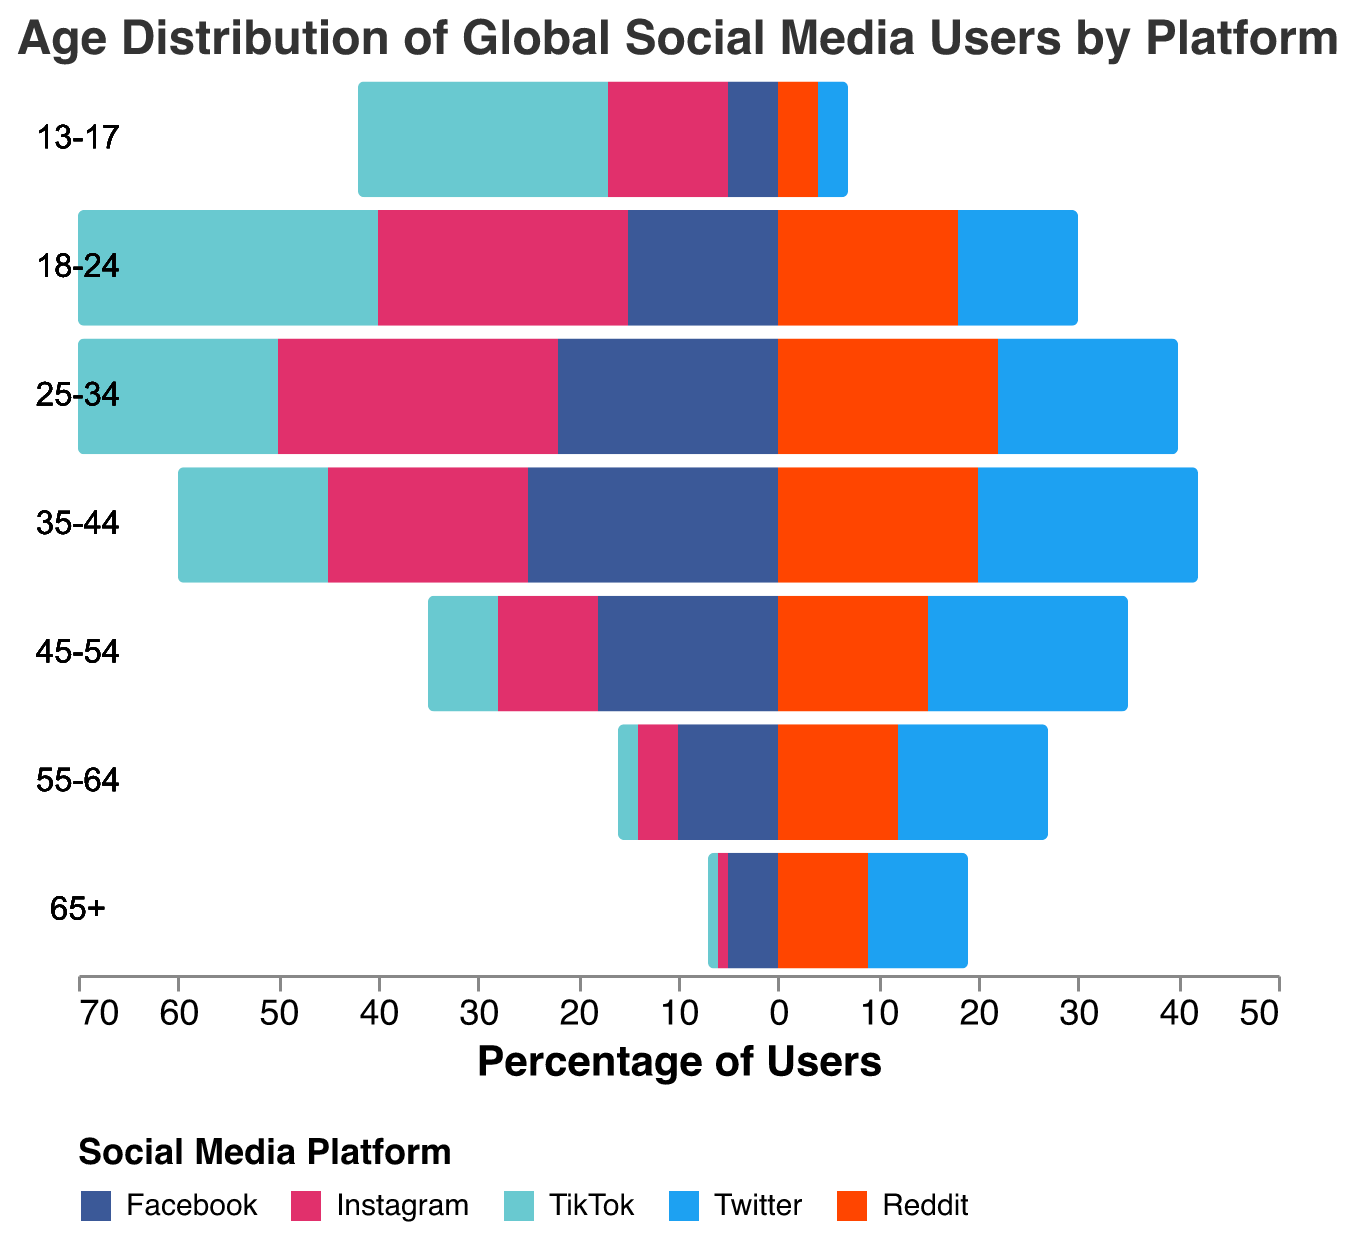What is the age group with the highest percentage of Facebook users? To find the age group with the highest percentage of Facebook users, refer to the bars representing Facebook in different age groups. The tallest bar indicates the age group with the highest percentage.
Answer: 35-44 Which social media platform has the highest user percentage among the 18-24 age group? Look for the bar corresponding to the 18-24 age group and identify the platform with the highest value.
Answer: TikTok How does the percentage of Instagram users in the 45-54 age group compare to the percentage of Reddit users in the same age group? Compare the heights of the Instagram and Reddit bars for the 45-54 age group.
Answer: Reddit is higher What is the combined percentage of TikTok users in the 13-17 and 18-24 age groups? Add the percentages of TikTok users for the 13-17 and 18-24 age groups: 25 (13-17) + 30 (18-24) = 55.
Answer: 55 Which age group has the smallest percentage of Instagram users? Identify the smallest bar for Instagram across all age groups.
Answer: 65+ What trend can be observed in the use of Facebook as age increases? Observe the pattern of Facebook bar heights across different age groups. The usage seems to peak in middle age and decrease towards the older and younger ends.
Answer: Peaks around 35-44, decreases towards edges Compare the percentage of TikTok users in the 25-34 and 55-64 age groups. Which is higher, and by how much? Subtract the percentage of TikTok users in 55-64 from 25-34: 20 (25-34) - 2 (55-64) = 18.
Answer: 25-34 is higher by 18 Which platform has a consistent decrease in percentage usage with increasing age? Look at the bars' height for each platform across age groups. The one that consistently decreases is Instagram.
Answer: Instagram Calculate the average percentage of Reddit users across all age groups. Sum the percentages of Reddit users across all age groups and divide by the number of age groups: (4+18+22+20+15+12+9)/7 = 100/7 ≈ 14.3
Answer: 14.3 What is the difference in the percentage of Twitter users between the 35-44 age group and the 65+ age group? Subtract the percentage of Twitter users in 65+ from 35-44: 22 (35-44) - 10 (65+) = 12.
Answer: 12 